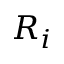Convert formula to latex. <formula><loc_0><loc_0><loc_500><loc_500>R _ { i }</formula> 